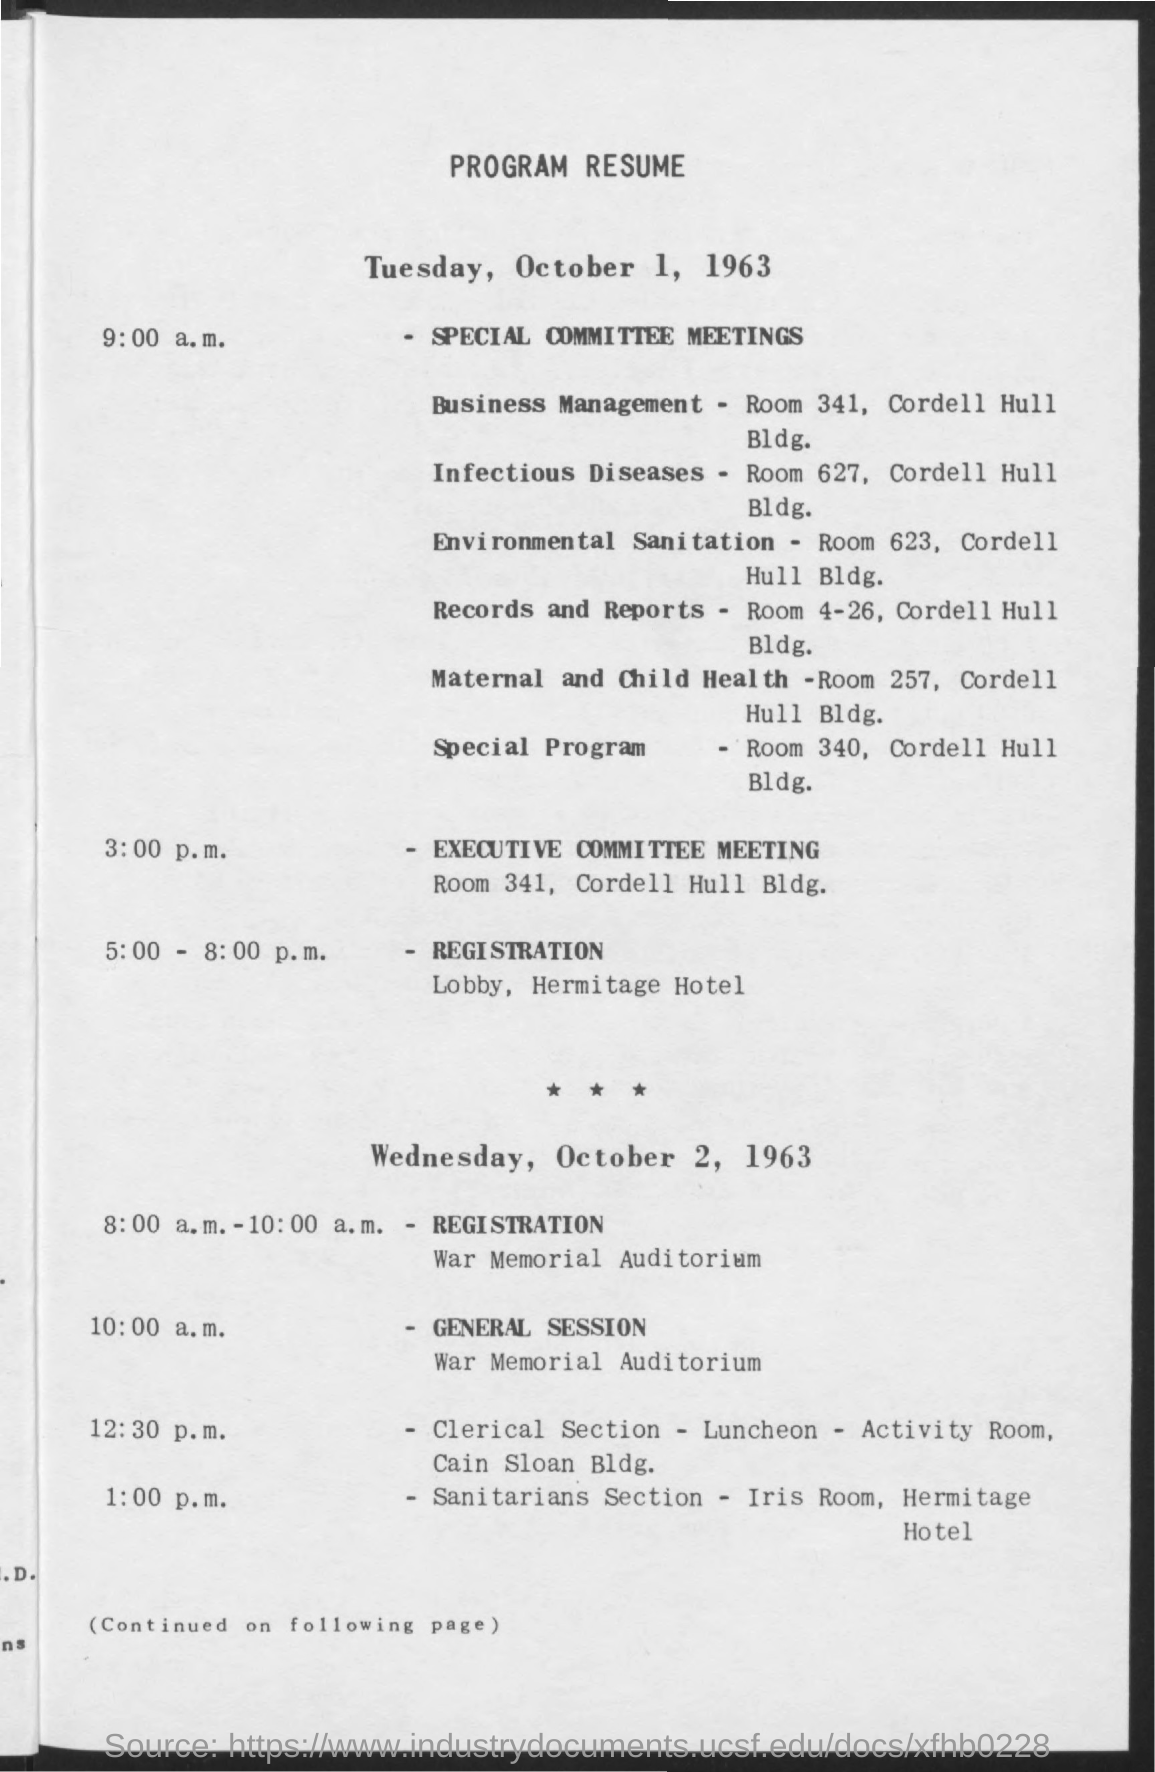What is the title of the document?
Make the answer very short. Program resume. 